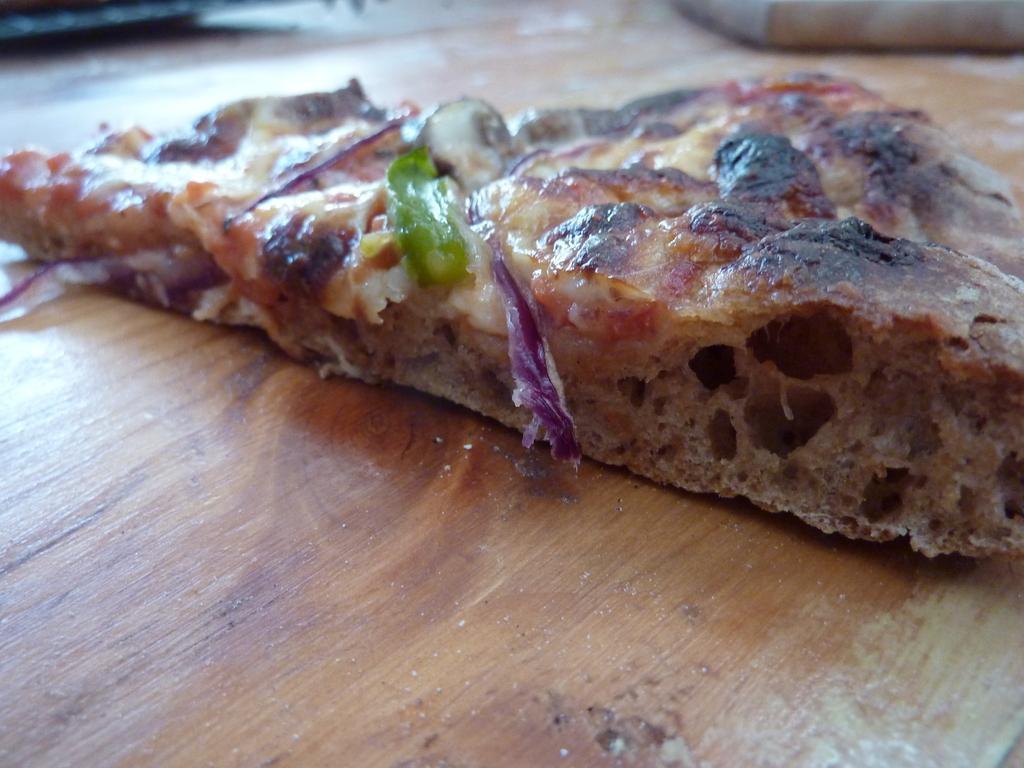Describe this image in one or two sentences. Here in this picture we can see a piece of pizza present on a table. 